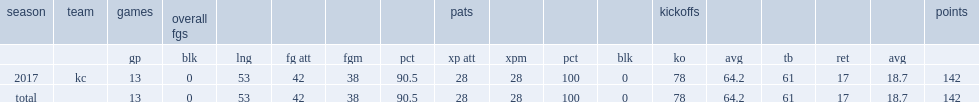How many points did harrison butker get in 2017? 142.0. 